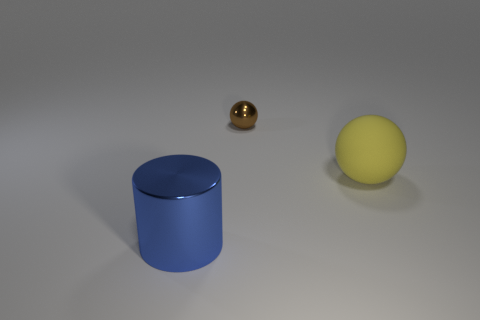Are there fewer yellow things that are in front of the yellow matte ball than large shiny things that are in front of the blue thing?
Offer a very short reply. No. How many large brown metal objects are there?
Your answer should be compact. 0. Are there any other things that have the same material as the yellow object?
Your response must be concise. No. There is another brown thing that is the same shape as the big matte object; what is its material?
Provide a succinct answer. Metal. Are there fewer brown spheres on the right side of the yellow rubber object than cyan balls?
Make the answer very short. No. There is a shiny thing on the right side of the large metal object; does it have the same shape as the large yellow matte thing?
Keep it short and to the point. Yes. Are there any other things of the same color as the tiny metallic thing?
Your response must be concise. No. The blue cylinder that is made of the same material as the brown thing is what size?
Provide a succinct answer. Large. What is the material of the ball in front of the ball that is behind the large thing that is to the right of the big blue metallic cylinder?
Ensure brevity in your answer.  Rubber. Are there fewer shiny cylinders than tiny matte cylinders?
Keep it short and to the point. No. 